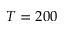Convert formula to latex. <formula><loc_0><loc_0><loc_500><loc_500>T = 2 0 0</formula> 